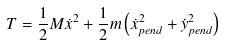<formula> <loc_0><loc_0><loc_500><loc_500>T = { \frac { 1 } { 2 } } M { \dot { x } } ^ { 2 } + { \frac { 1 } { 2 } } m \left ( { \dot { x } } _ { p e n d } ^ { 2 } + { \dot { y } } _ { p e n d } ^ { 2 } \right )</formula> 